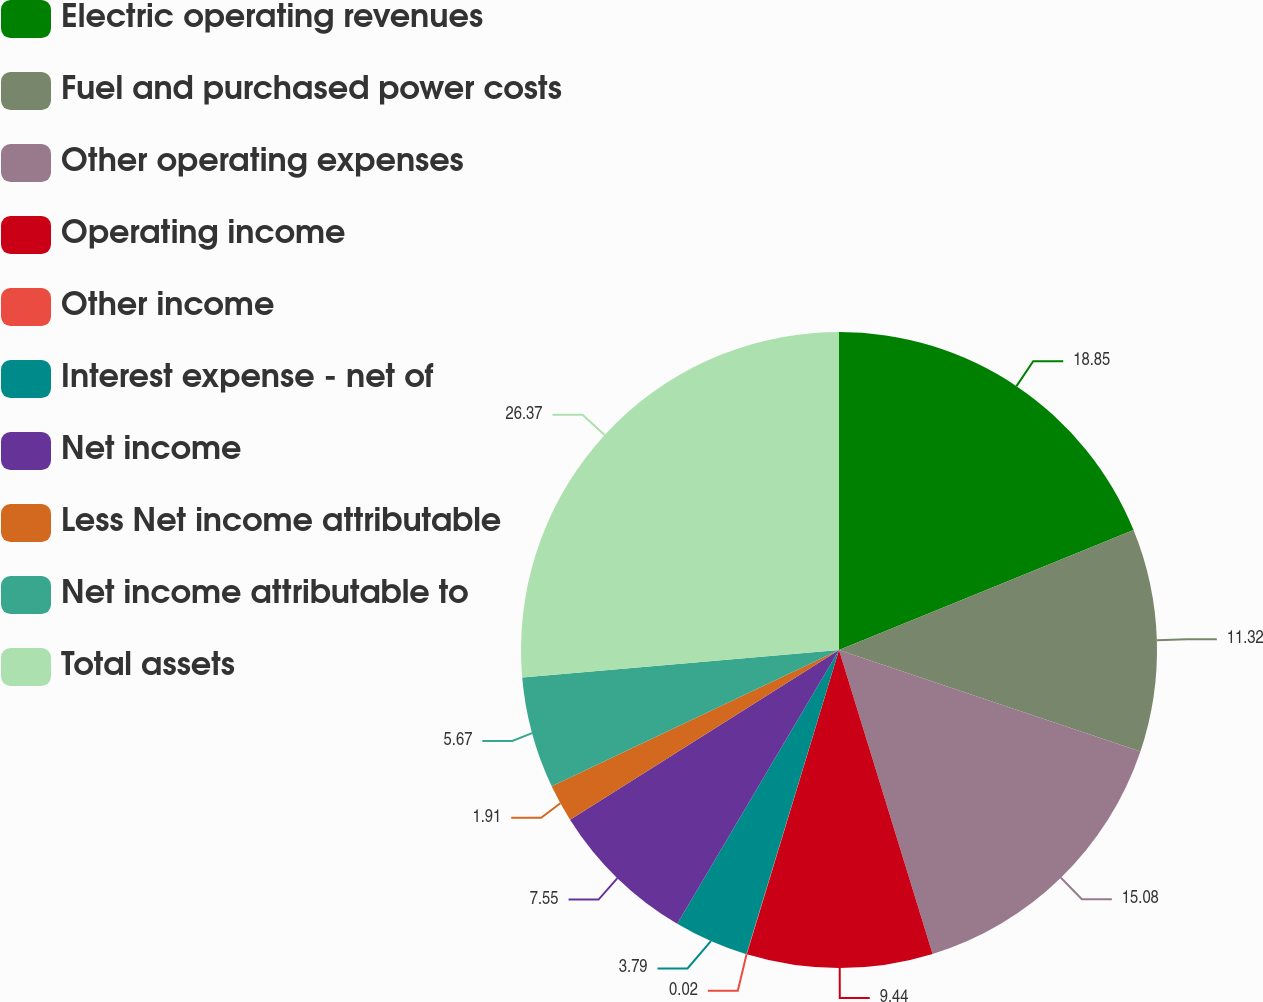Convert chart. <chart><loc_0><loc_0><loc_500><loc_500><pie_chart><fcel>Electric operating revenues<fcel>Fuel and purchased power costs<fcel>Other operating expenses<fcel>Operating income<fcel>Other income<fcel>Interest expense - net of<fcel>Net income<fcel>Less Net income attributable<fcel>Net income attributable to<fcel>Total assets<nl><fcel>18.85%<fcel>11.32%<fcel>15.08%<fcel>9.44%<fcel>0.02%<fcel>3.79%<fcel>7.55%<fcel>1.91%<fcel>5.67%<fcel>26.38%<nl></chart> 